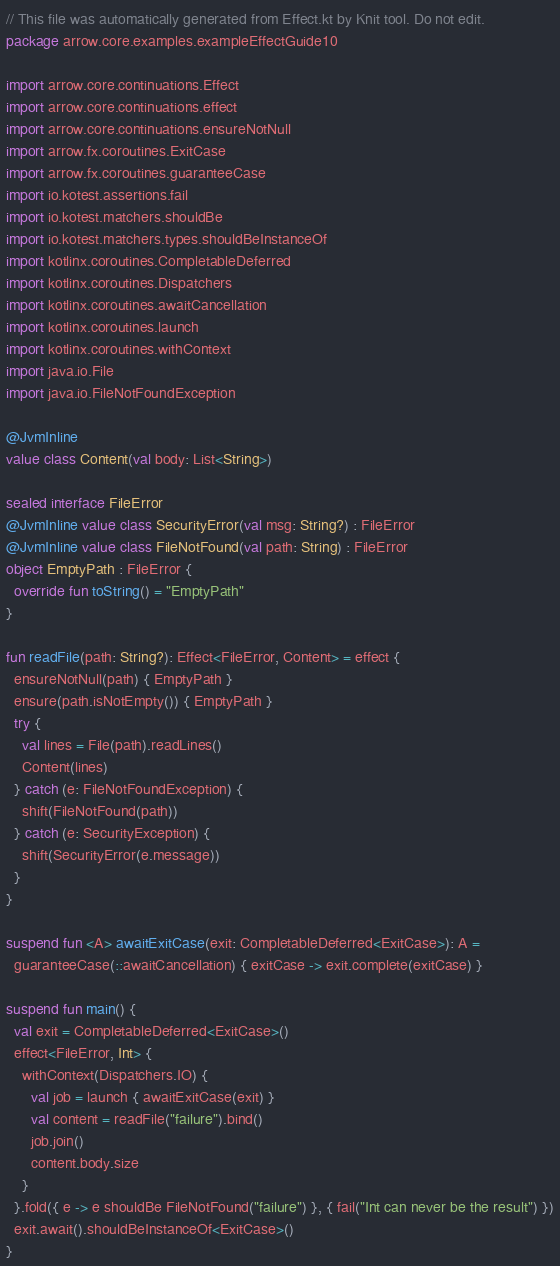<code> <loc_0><loc_0><loc_500><loc_500><_Kotlin_>// This file was automatically generated from Effect.kt by Knit tool. Do not edit.
package arrow.core.examples.exampleEffectGuide10

import arrow.core.continuations.Effect
import arrow.core.continuations.effect
import arrow.core.continuations.ensureNotNull
import arrow.fx.coroutines.ExitCase
import arrow.fx.coroutines.guaranteeCase
import io.kotest.assertions.fail
import io.kotest.matchers.shouldBe
import io.kotest.matchers.types.shouldBeInstanceOf
import kotlinx.coroutines.CompletableDeferred
import kotlinx.coroutines.Dispatchers
import kotlinx.coroutines.awaitCancellation
import kotlinx.coroutines.launch
import kotlinx.coroutines.withContext
import java.io.File
import java.io.FileNotFoundException

@JvmInline
value class Content(val body: List<String>)

sealed interface FileError
@JvmInline value class SecurityError(val msg: String?) : FileError
@JvmInline value class FileNotFound(val path: String) : FileError
object EmptyPath : FileError {
  override fun toString() = "EmptyPath"
}

fun readFile(path: String?): Effect<FileError, Content> = effect {
  ensureNotNull(path) { EmptyPath }
  ensure(path.isNotEmpty()) { EmptyPath }
  try {
    val lines = File(path).readLines()
    Content(lines)
  } catch (e: FileNotFoundException) {
    shift(FileNotFound(path))
  } catch (e: SecurityException) {
    shift(SecurityError(e.message))
  }
}

suspend fun <A> awaitExitCase(exit: CompletableDeferred<ExitCase>): A =
  guaranteeCase(::awaitCancellation) { exitCase -> exit.complete(exitCase) }

suspend fun main() {
  val exit = CompletableDeferred<ExitCase>()
  effect<FileError, Int> {
    withContext(Dispatchers.IO) {
      val job = launch { awaitExitCase(exit) }
      val content = readFile("failure").bind()
      job.join()
      content.body.size
    }
  }.fold({ e -> e shouldBe FileNotFound("failure") }, { fail("Int can never be the result") })
  exit.await().shouldBeInstanceOf<ExitCase>()
}
</code> 